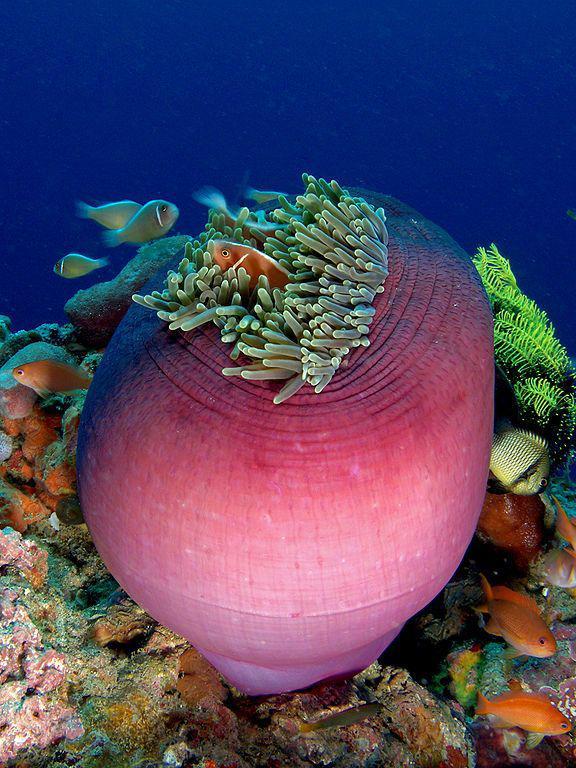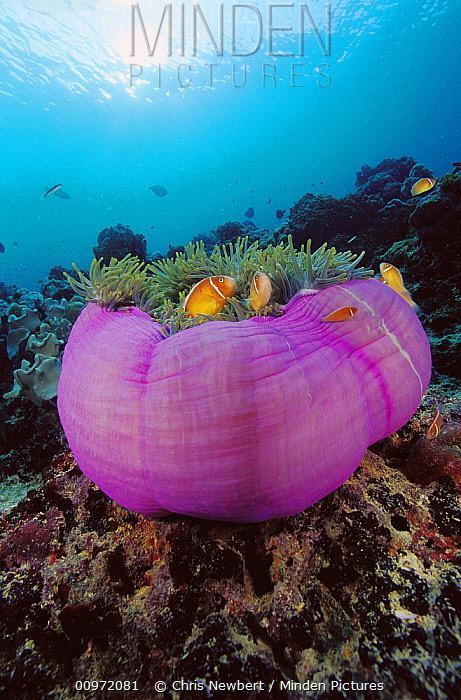The first image is the image on the left, the second image is the image on the right. Examine the images to the left and right. Is the description "In there water there are at least 5 corral pieces with two tone colored arms." accurate? Answer yes or no. No. The first image is the image on the left, the second image is the image on the right. Evaluate the accuracy of this statement regarding the images: "There are fish hiding inside the anemone.". Is it true? Answer yes or no. Yes. 